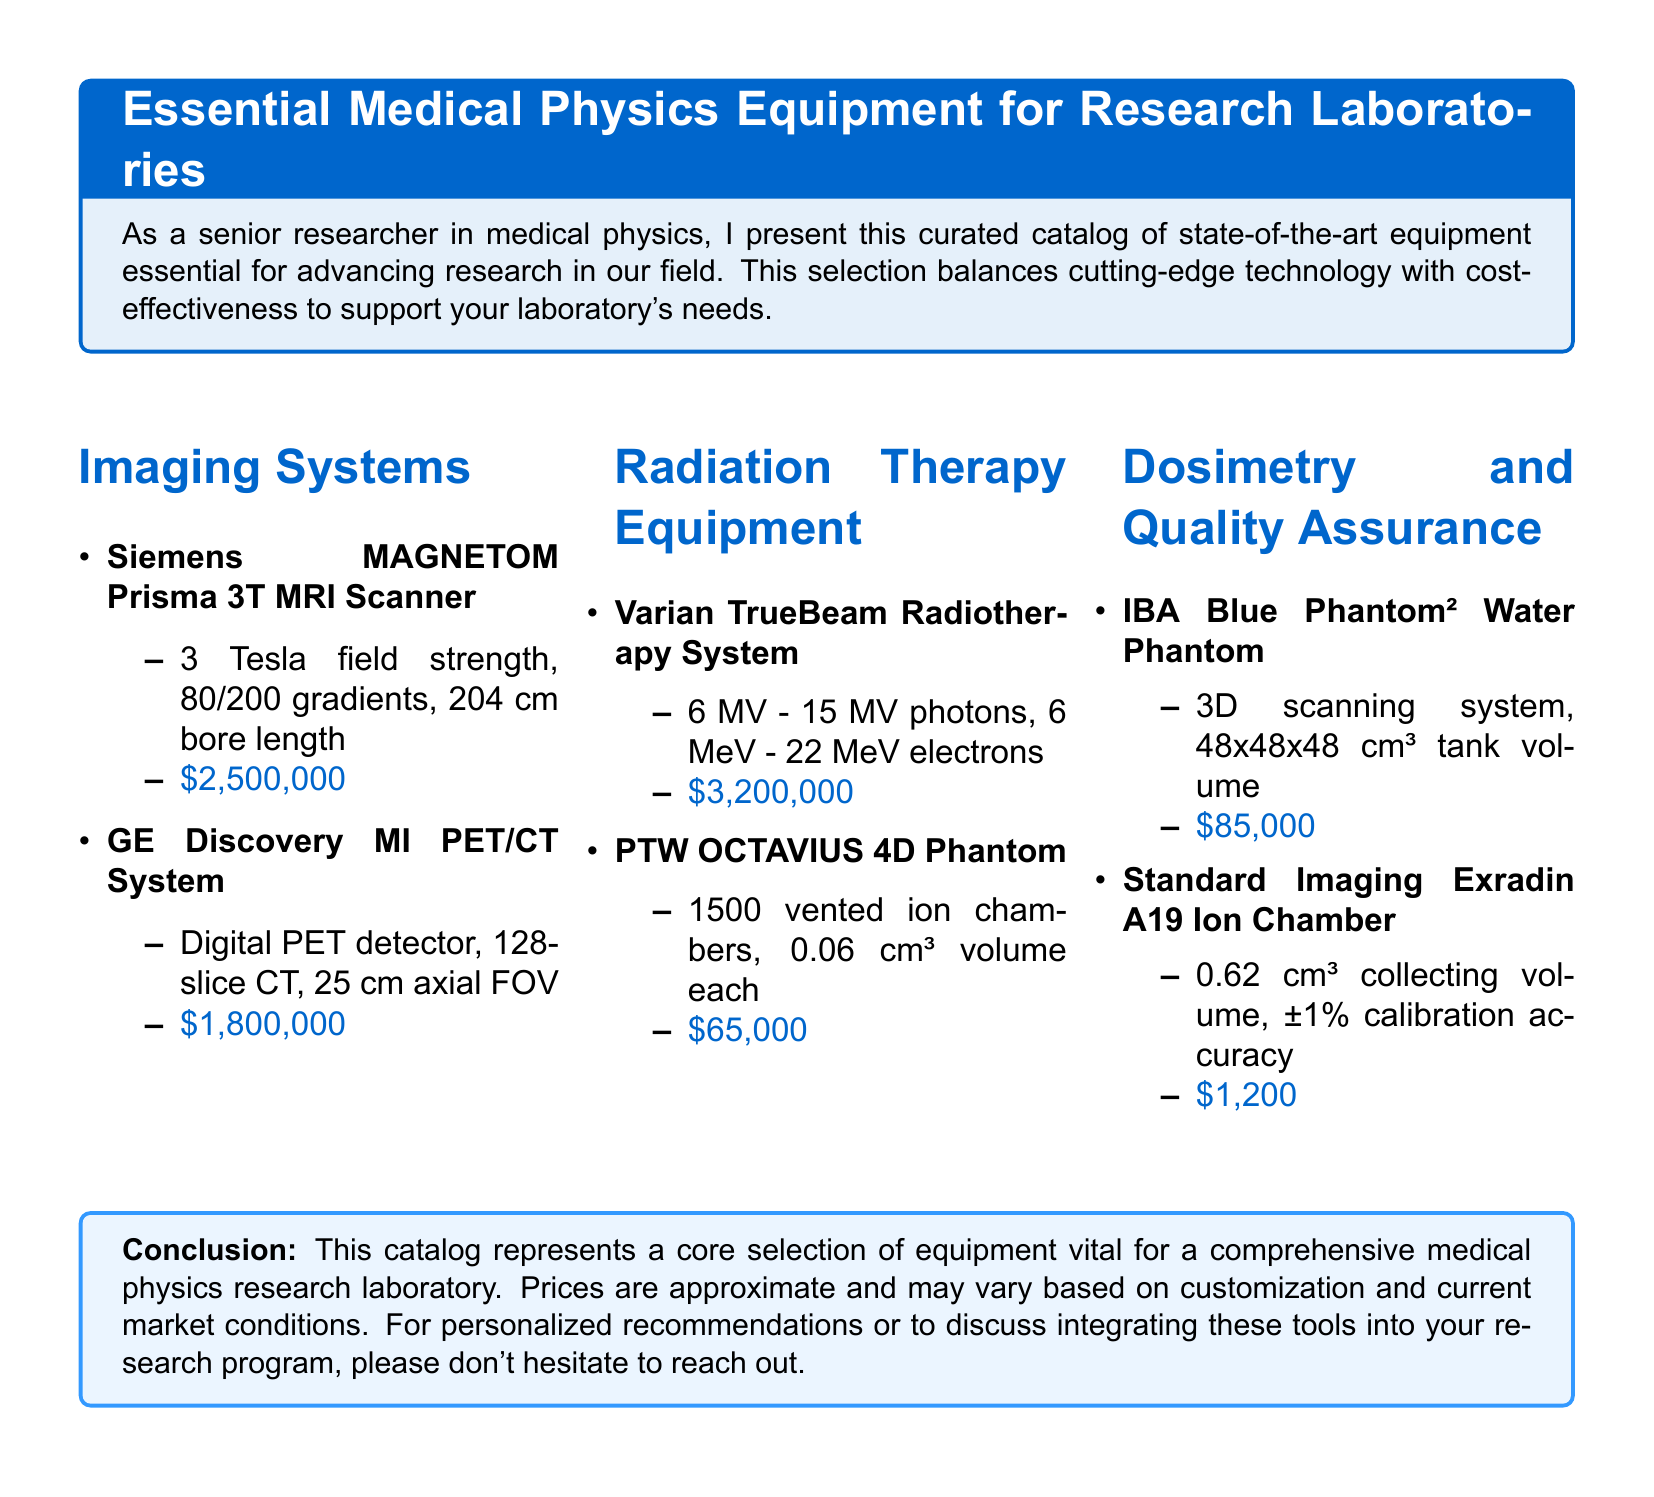What is the price of the Siemens MAGNETOM Prisma 3T MRI Scanner? The price of the Siemens MAGNETOM Prisma 3T MRI Scanner is stated in the document as $2,500,000.
Answer: $2,500,000 How many slices does the GE Discovery MI PET/CT System have? The document specifies that the GE Discovery MI PET/CT System has 128 slices.
Answer: 128-slice What is the calibration accuracy of the Standard Imaging Exradin A19 Ion Chamber? The document mentions that the calibration accuracy of the Standard Imaging Exradin A19 Ion Chamber is ±1%.
Answer: ±1% Which imaging system has the highest cost listed in the document? The reasoning involves comparing prices of imaging systems; the Varian TrueBeam Radiotherapy System is the only one that exceeds the others.
Answer: Varian TrueBeam Radiotherapy System What volume is the IBA Blue Phantom² Water Phantom? The document indicates that the volume of the IBA Blue Phantom² Water Phantom is 48x48x48 cm³.
Answer: 48x48x48 cm³ How many ion chambers are in the PTW OCTAVIUS 4D Phantom? The document specifies that the PTW OCTAVIUS 4D Phantom has 1500 vented ion chambers.
Answer: 1500 What is the total approximate price for the listed imaging systems? This involves summing the prices for all imaging systems: $2,500,000 + $1,800,000 = $4,300,000.
Answer: $4,300,000 What is the bore length of the Siemens MAGNETOM Prisma 3T MRI Scanner? The document states that the bore length of the Siemens MAGNETOM Prisma 3T MRI Scanner is 204 cm.
Answer: 204 cm 